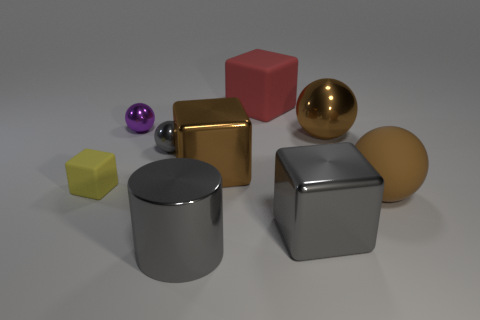There is a matte thing left of the small ball in front of the small purple object that is behind the tiny rubber object; what color is it?
Offer a very short reply. Yellow. Are there an equal number of large rubber things in front of the gray metal cube and big metal things?
Offer a very short reply. No. Is there anything else that is the same material as the purple ball?
Offer a very short reply. Yes. Do the large rubber block and the small metal ball behind the large shiny ball have the same color?
Give a very brief answer. No. Is there a tiny gray object in front of the rubber block that is to the left of the big metallic thing in front of the gray metal block?
Give a very brief answer. No. Is the number of gray objects right of the brown metallic sphere less than the number of shiny spheres?
Keep it short and to the point. Yes. How many other objects are the same shape as the large brown matte object?
Provide a succinct answer. 3. What number of objects are gray objects that are behind the gray metal block or objects that are on the right side of the gray metallic cylinder?
Provide a short and direct response. 6. What size is the cube that is both in front of the tiny purple ball and behind the tiny matte cube?
Give a very brief answer. Large. There is a brown object that is behind the tiny gray metal sphere; is its shape the same as the small purple thing?
Keep it short and to the point. Yes. 